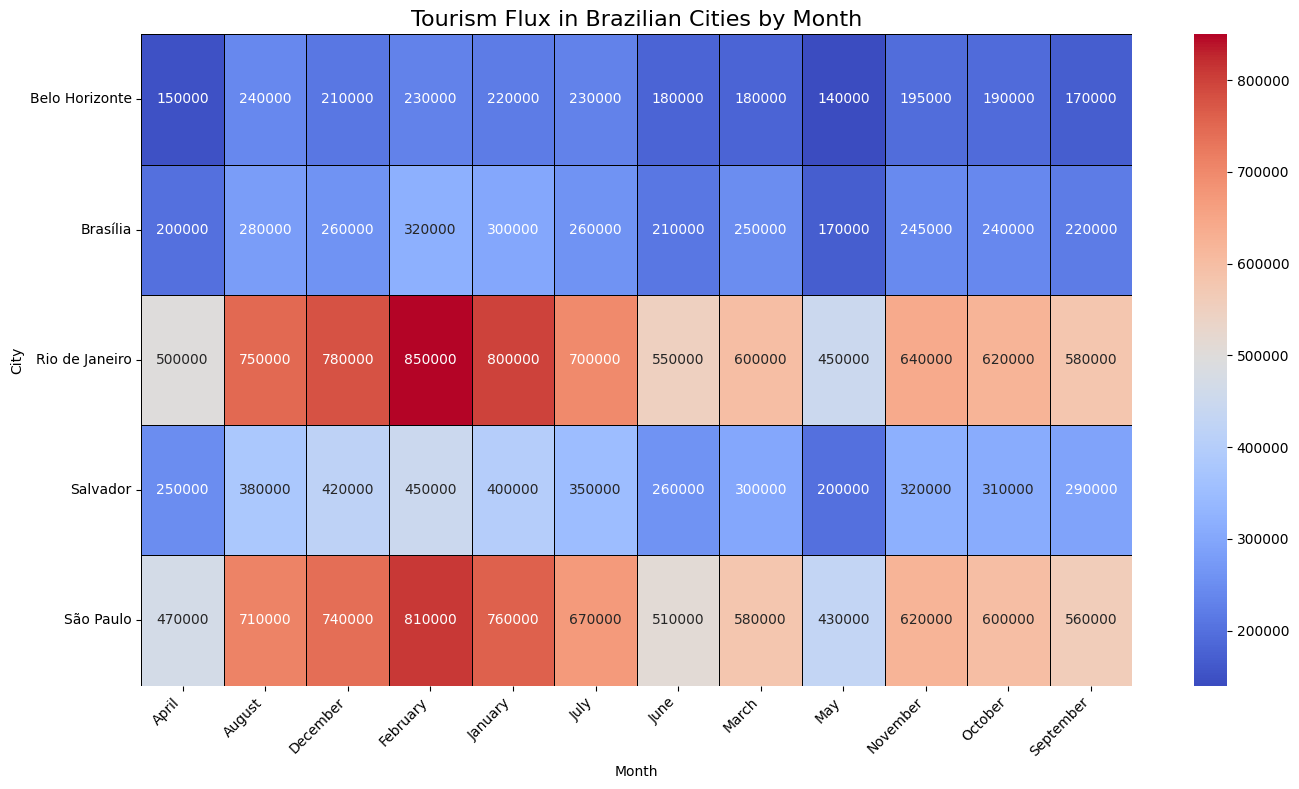what is the total number of tourists throughout the year in Rio de Janeiro? To find the total number of tourists in Rio de Janeiro throughout the year, sum the tourist numbers for all months: 800000 (Jan) + 850000 (Feb) + 600000 (Mar) + 500000 (Apr) + 450000 (May) + 550000 (Jun) + 700000 (Jul) + 750000 (Aug) + 580000 (Sep) + 620000 (Oct) + 640000 (Nov) + 780000 (Dec) = 8320000
Answer: 8320000 Which city had the highest number of tourists in February? Compare the number of tourists in February across all cities: Rio de Janeiro (850000), São Paulo (810000), Salvador (450000), Belo Horizonte (230000), and Brasília (320000). The highest value is 850000 for Rio de Janeiro
Answer: Rio de Janeiro Between Salvador and Brasília, which city had more tourists in July? Look at the number of tourists in July for both cities: Salvador (350000) and Brasília (260000). Salvador has more tourists in July
Answer: Salvador During which months did São Paulo receive fewer tourists than Belo Horizonte? Compare monthly tourist numbers between São Paulo and Belo Horizonte: January (760000 > 220000), February (810000 > 230000), March (580000 > 180000), April (470000 > 150000), May (430000 > 140000), June (510000 > 180000), July (670000 > 230000), August (710000 > 240000), September (560000 > 170000), October (600000 > 190000), November (620000 > 195000), December (740000 > 210000). São Paulo has more tourists every month, so there are no months where São Paulo received fewer tourists than Belo Horizonte
Answer: none Which city had the most consistent number of tourists throughout the year? Evaluate the variation in tourist numbers for each city. Calculate the range (difference between maximum and minimum values) for each: Rio de Janeiro (850000 - 450000 = 400000), São Paulo (810000 - 430000 = 380000), Salvador (450000 - 200000 = 250000), Belo Horizonte (240000 - 140000 = 100000), Brasília (320000 - 170000 = 150000). The city with the smallest range is Belo Horizonte
Answer: Belo Horizonte 